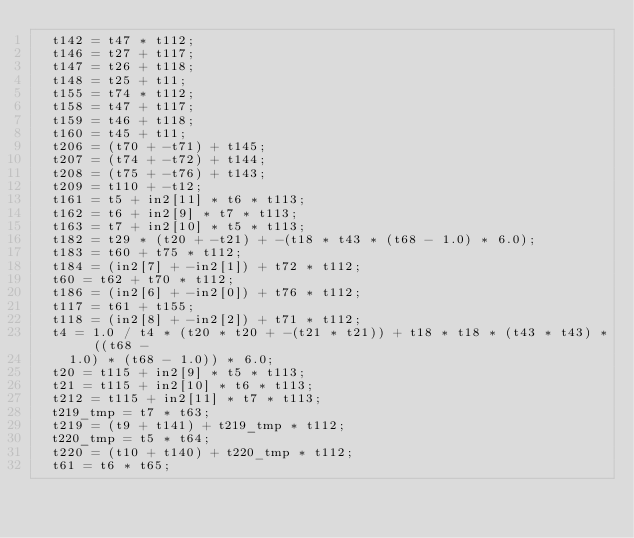Convert code to text. <code><loc_0><loc_0><loc_500><loc_500><_C_>  t142 = t47 * t112;
  t146 = t27 + t117;
  t147 = t26 + t118;
  t148 = t25 + t11;
  t155 = t74 * t112;
  t158 = t47 + t117;
  t159 = t46 + t118;
  t160 = t45 + t11;
  t206 = (t70 + -t71) + t145;
  t207 = (t74 + -t72) + t144;
  t208 = (t75 + -t76) + t143;
  t209 = t110 + -t12;
  t161 = t5 + in2[11] * t6 * t113;
  t162 = t6 + in2[9] * t7 * t113;
  t163 = t7 + in2[10] * t5 * t113;
  t182 = t29 * (t20 + -t21) + -(t18 * t43 * (t68 - 1.0) * 6.0);
  t183 = t60 + t75 * t112;
  t184 = (in2[7] + -in2[1]) + t72 * t112;
  t60 = t62 + t70 * t112;
  t186 = (in2[6] + -in2[0]) + t76 * t112;
  t117 = t61 + t155;
  t118 = (in2[8] + -in2[2]) + t71 * t112;
  t4 = 1.0 / t4 * (t20 * t20 + -(t21 * t21)) + t18 * t18 * (t43 * t43) * ((t68 -
    1.0) * (t68 - 1.0)) * 6.0;
  t20 = t115 + in2[9] * t5 * t113;
  t21 = t115 + in2[10] * t6 * t113;
  t212 = t115 + in2[11] * t7 * t113;
  t219_tmp = t7 * t63;
  t219 = (t9 + t141) + t219_tmp * t112;
  t220_tmp = t5 * t64;
  t220 = (t10 + t140) + t220_tmp * t112;
  t61 = t6 * t65;</code> 